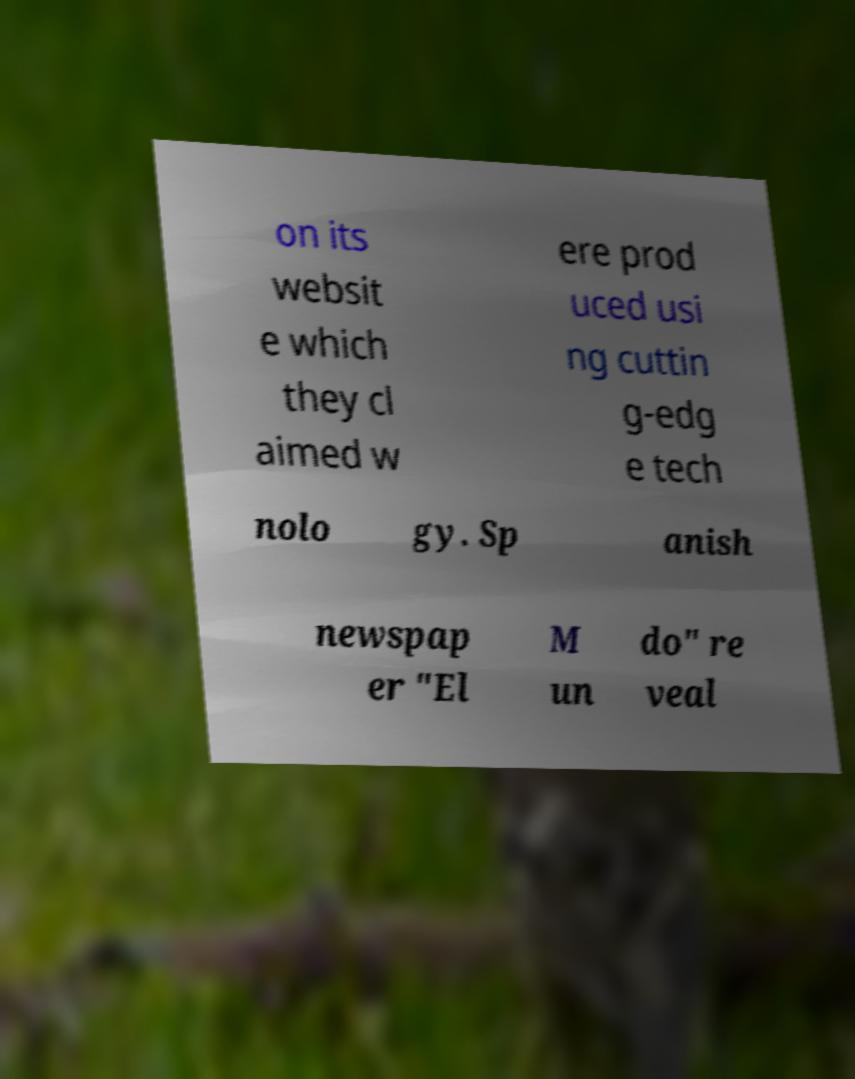I need the written content from this picture converted into text. Can you do that? on its websit e which they cl aimed w ere prod uced usi ng cuttin g-edg e tech nolo gy. Sp anish newspap er "El M un do" re veal 